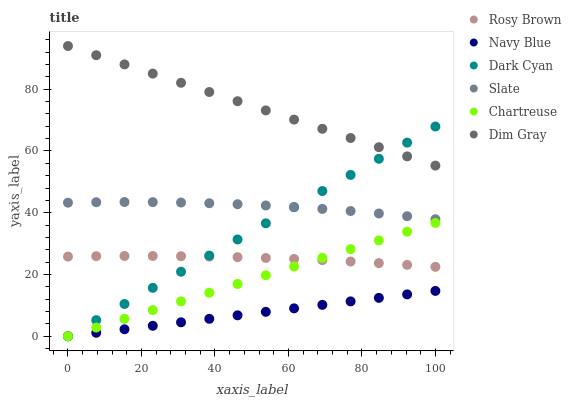Does Navy Blue have the minimum area under the curve?
Answer yes or no. Yes. Does Dim Gray have the maximum area under the curve?
Answer yes or no. Yes. Does Slate have the minimum area under the curve?
Answer yes or no. No. Does Slate have the maximum area under the curve?
Answer yes or no. No. Is Navy Blue the smoothest?
Answer yes or no. Yes. Is Slate the roughest?
Answer yes or no. Yes. Is Slate the smoothest?
Answer yes or no. No. Is Navy Blue the roughest?
Answer yes or no. No. Does Navy Blue have the lowest value?
Answer yes or no. Yes. Does Slate have the lowest value?
Answer yes or no. No. Does Dim Gray have the highest value?
Answer yes or no. Yes. Does Slate have the highest value?
Answer yes or no. No. Is Chartreuse less than Slate?
Answer yes or no. Yes. Is Slate greater than Navy Blue?
Answer yes or no. Yes. Does Navy Blue intersect Dark Cyan?
Answer yes or no. Yes. Is Navy Blue less than Dark Cyan?
Answer yes or no. No. Is Navy Blue greater than Dark Cyan?
Answer yes or no. No. Does Chartreuse intersect Slate?
Answer yes or no. No. 